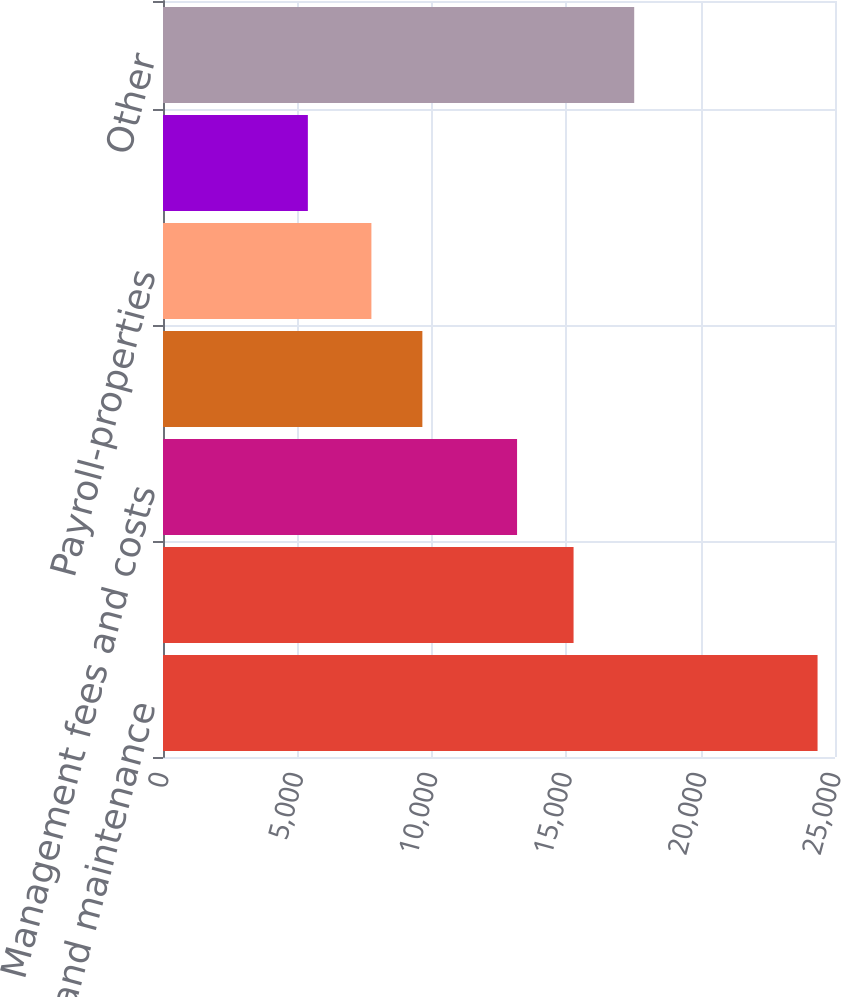Convert chart. <chart><loc_0><loc_0><loc_500><loc_500><bar_chart><fcel>Repairs and maintenance<fcel>Utilities<fcel>Management fees and costs<fcel>Insurance<fcel>Payroll-properties<fcel>Ground rent<fcel>Other<nl><fcel>24351<fcel>15274<fcel>13172<fcel>9649.2<fcel>7753<fcel>5389<fcel>17530<nl></chart> 